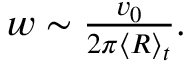Convert formula to latex. <formula><loc_0><loc_0><loc_500><loc_500>\begin{array} { r } { w \sim \frac { v _ { 0 } } { 2 \pi \langle R \rangle _ { t } } . } \end{array}</formula> 